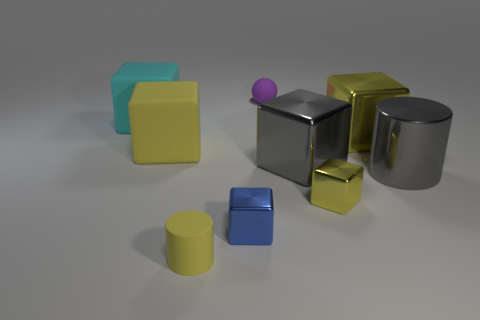There is a large metal cylinder; is it the same color as the big metallic thing left of the big yellow metal thing?
Offer a very short reply. Yes. Do the tiny matte thing that is in front of the tiny purple ball and the tiny cube to the right of the tiny rubber ball have the same color?
Keep it short and to the point. Yes. What size is the blue cube in front of the yellow matte thing that is to the left of the yellow matte object that is in front of the gray shiny cube?
Provide a succinct answer. Small. Does the purple rubber object have the same size as the metallic cylinder?
Offer a very short reply. No. Is there a tiny purple matte sphere behind the big yellow block on the right side of the tiny purple ball?
Offer a very short reply. Yes. The metallic block that is the same color as the large cylinder is what size?
Your answer should be compact. Large. There is a tiny yellow thing to the right of the gray block; what shape is it?
Your answer should be very brief. Cube. What number of small objects are to the right of the big gray metallic cylinder in front of the large yellow cube on the left side of the rubber sphere?
Your response must be concise. 0. There is a cyan block; is it the same size as the matte cube that is in front of the cyan block?
Make the answer very short. Yes. What size is the cylinder that is on the right side of the small matte thing that is to the left of the purple sphere?
Provide a succinct answer. Large. 